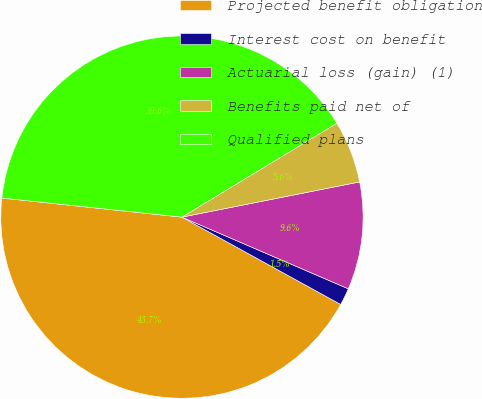Convert chart to OTSL. <chart><loc_0><loc_0><loc_500><loc_500><pie_chart><fcel>Projected benefit obligation<fcel>Interest cost on benefit<fcel>Actuarial loss (gain) (1)<fcel>Benefits paid net of<fcel>Qualified plans<nl><fcel>43.68%<fcel>1.53%<fcel>9.59%<fcel>5.56%<fcel>39.65%<nl></chart> 